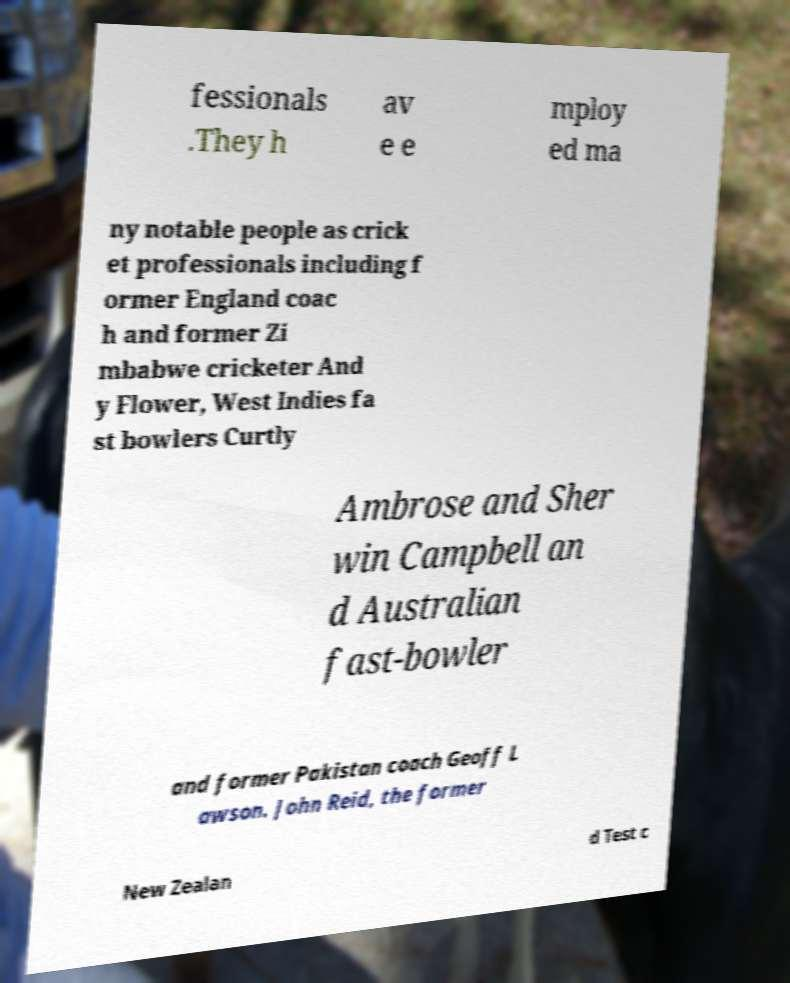Could you assist in decoding the text presented in this image and type it out clearly? fessionals .They h av e e mploy ed ma ny notable people as crick et professionals including f ormer England coac h and former Zi mbabwe cricketer And y Flower, West Indies fa st bowlers Curtly Ambrose and Sher win Campbell an d Australian fast-bowler and former Pakistan coach Geoff L awson. John Reid, the former New Zealan d Test c 